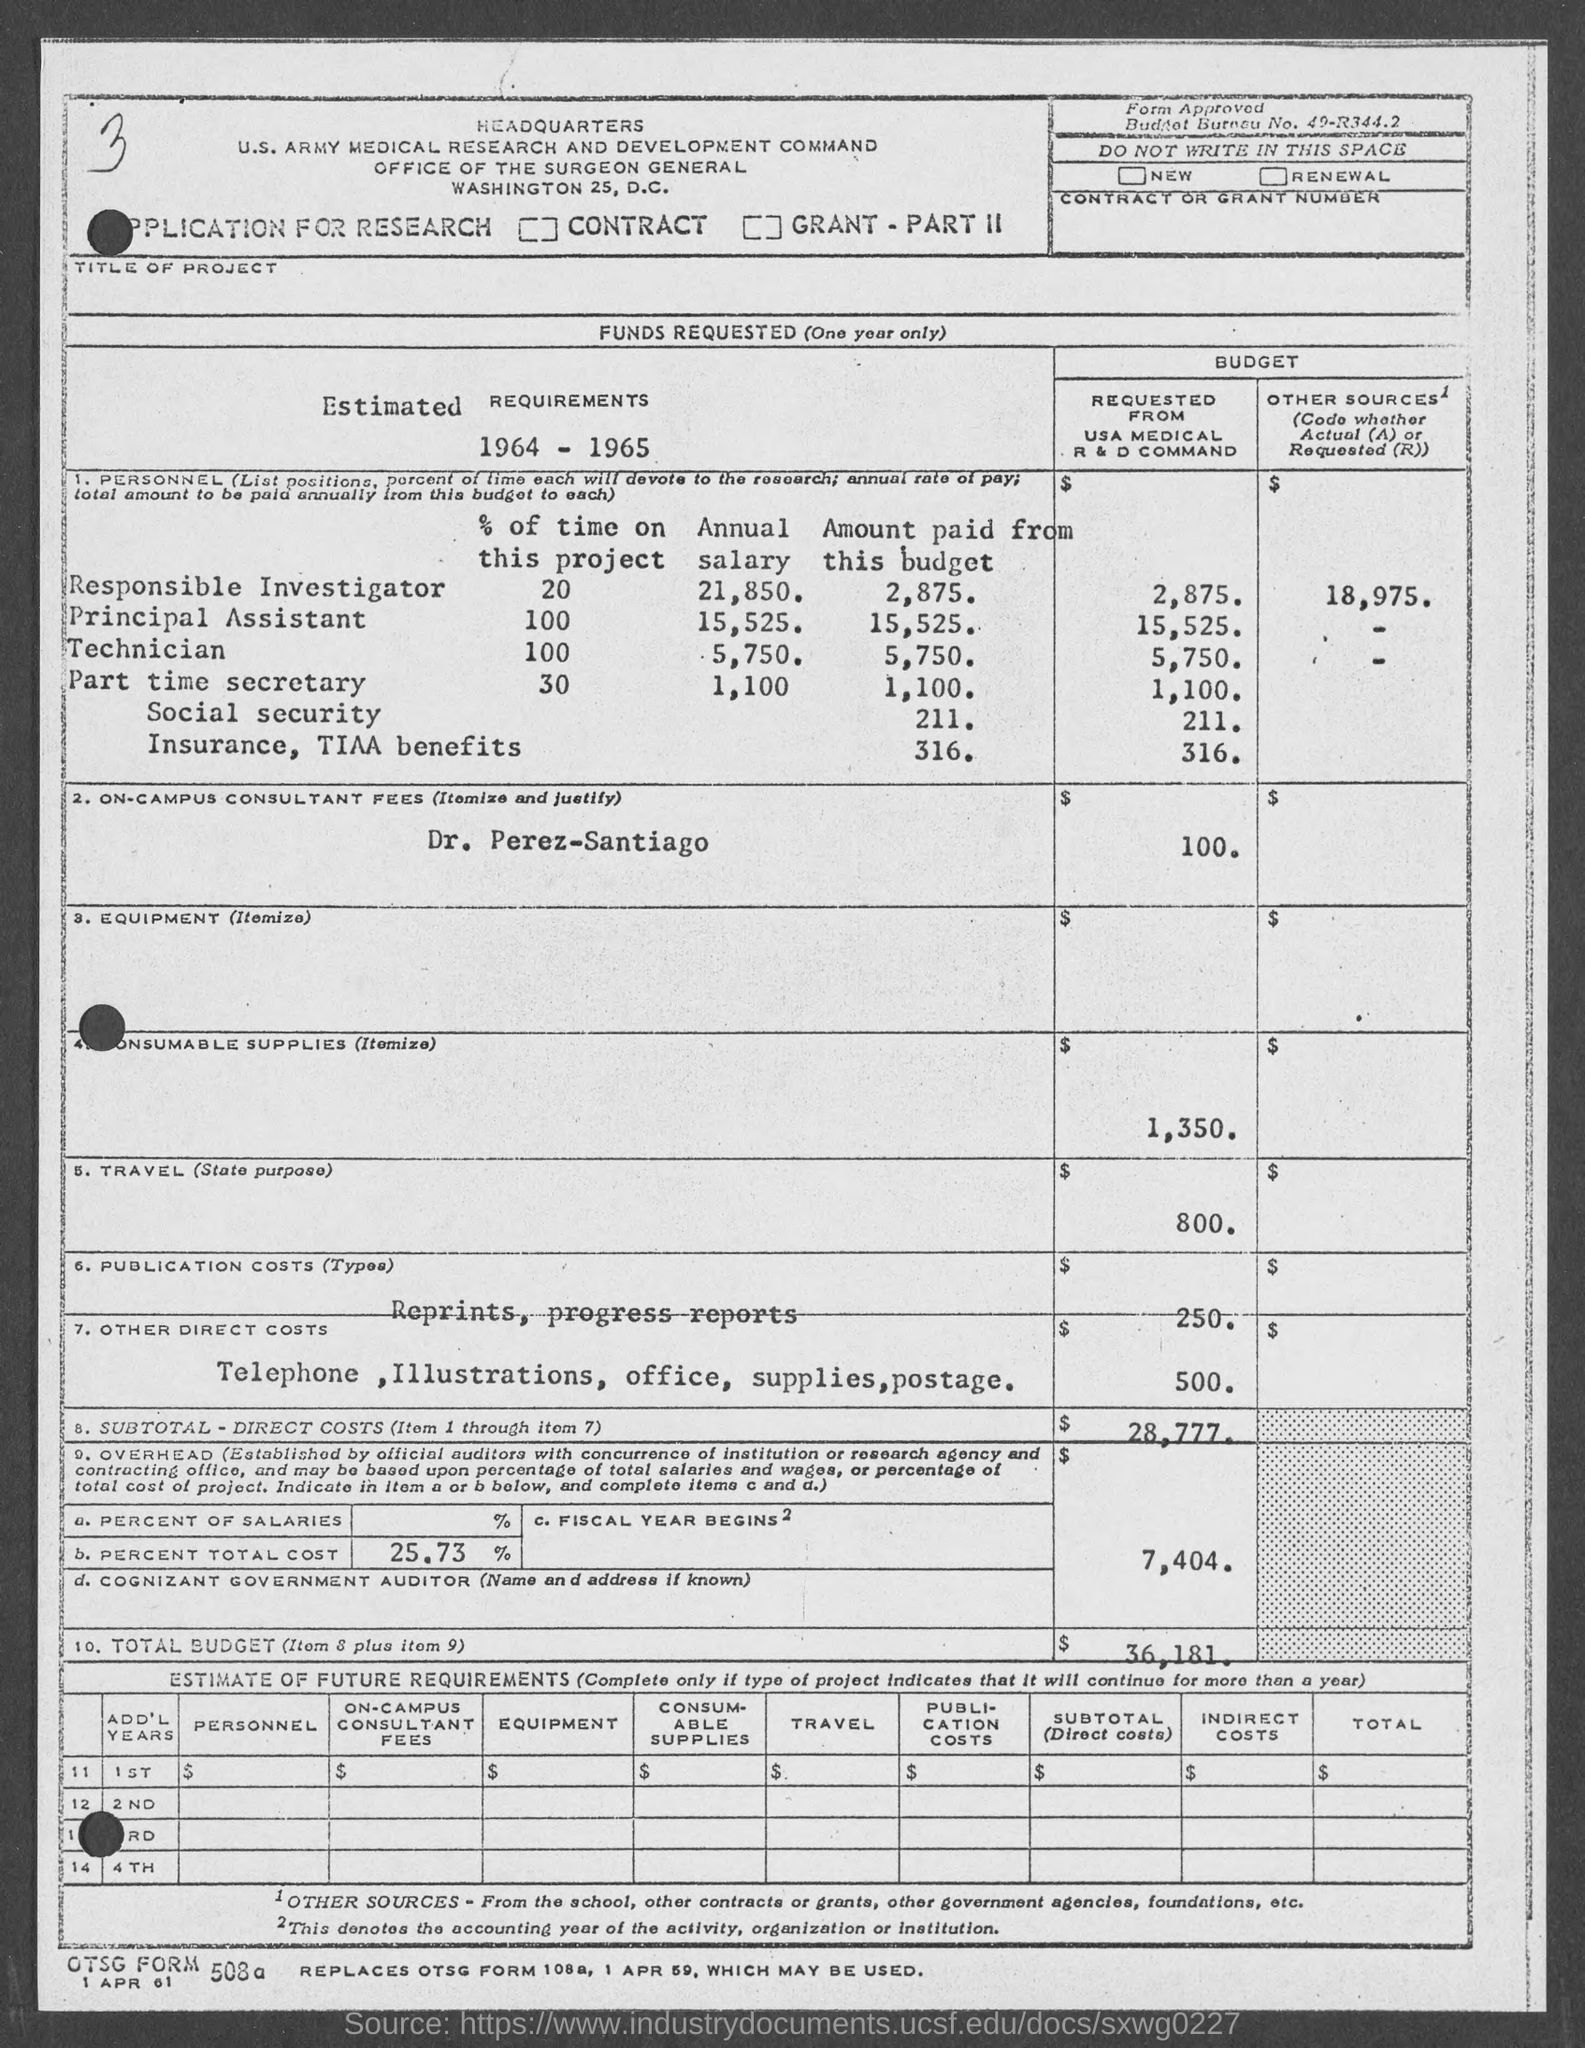What is the annual salary for the responsible investigator as mentioned in the given page ?
Provide a short and direct response. 21,850. What is the annual salary for the principal assistant as mentioned in the given page ?
Provide a succinct answer. 15,525. What is the annual salary for the technician  as mentioned in the given page ?
Make the answer very short. 5,750. What is the annual salary for the part time secretary as mentioned in the given page ?
Provide a succinct answer. 1,100. What is the amount for consumable supplies as mentioned in the given page ?
Keep it short and to the point. $ 1,350. What is the amount for travel as mentioned in the given page ?
Give a very brief answer. $ 800. What is the amount for publication costs as mentioned in the given page ?
Make the answer very short. $ 250. What is the amount for other costs as mentioned in the given page ?
Your answer should be compact. $ 500. What is the amount for sub total direct costs as mentioned in the given page ?
Give a very brief answer. $ 28,777. What is the percent total cost mentioned in the given page ?
Your response must be concise. 25.73%. 